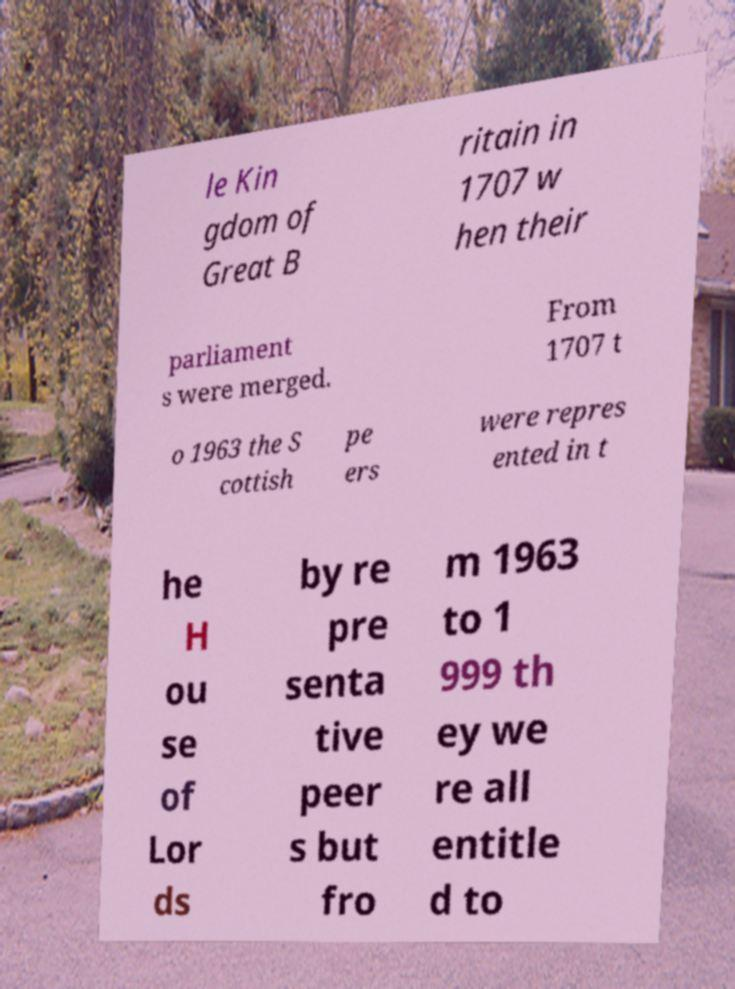Please identify and transcribe the text found in this image. le Kin gdom of Great B ritain in 1707 w hen their parliament s were merged. From 1707 t o 1963 the S cottish pe ers were repres ented in t he H ou se of Lor ds by re pre senta tive peer s but fro m 1963 to 1 999 th ey we re all entitle d to 